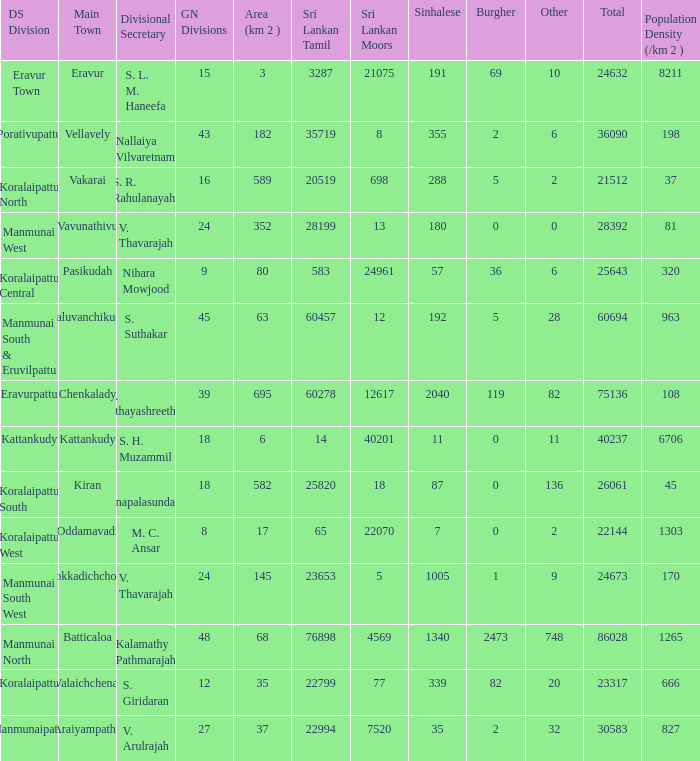Kaluvanchikudy is the main town in what DS division? Manmunai South & Eruvilpattu. 